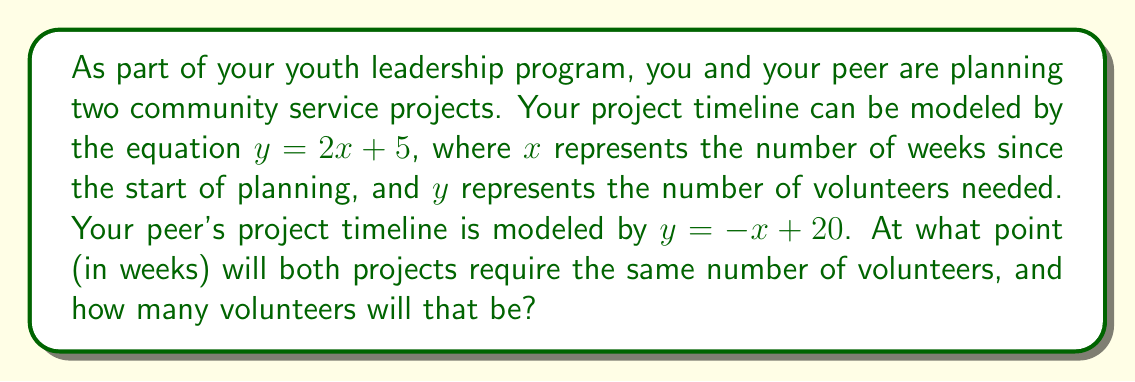Solve this math problem. To find the intersection point of these two project timelines, we need to solve the system of equations:

$$\begin{cases}
y = 2x + 5 \\
y = -x + 20
\end{cases}$$

Since both equations are equal to $y$, we can set them equal to each other:

$$2x + 5 = -x + 20$$

Now, let's solve for $x$:

1) Add $x$ to both sides:
   $$3x + 5 = 20$$

2) Subtract 5 from both sides:
   $$3x = 15$$

3) Divide both sides by 3:
   $$x = 5$$

This means the projects will require the same number of volunteers after 5 weeks.

To find the number of volunteers at this point, we can substitute $x = 5$ into either of the original equations. Let's use the first one:

$$y = 2x + 5$$
$$y = 2(5) + 5$$
$$y = 10 + 5 = 15$$

Therefore, after 5 weeks, both projects will require 15 volunteers.
Answer: The projects will require the same number of volunteers after 5 weeks, and at that point, they will both need 15 volunteers. 